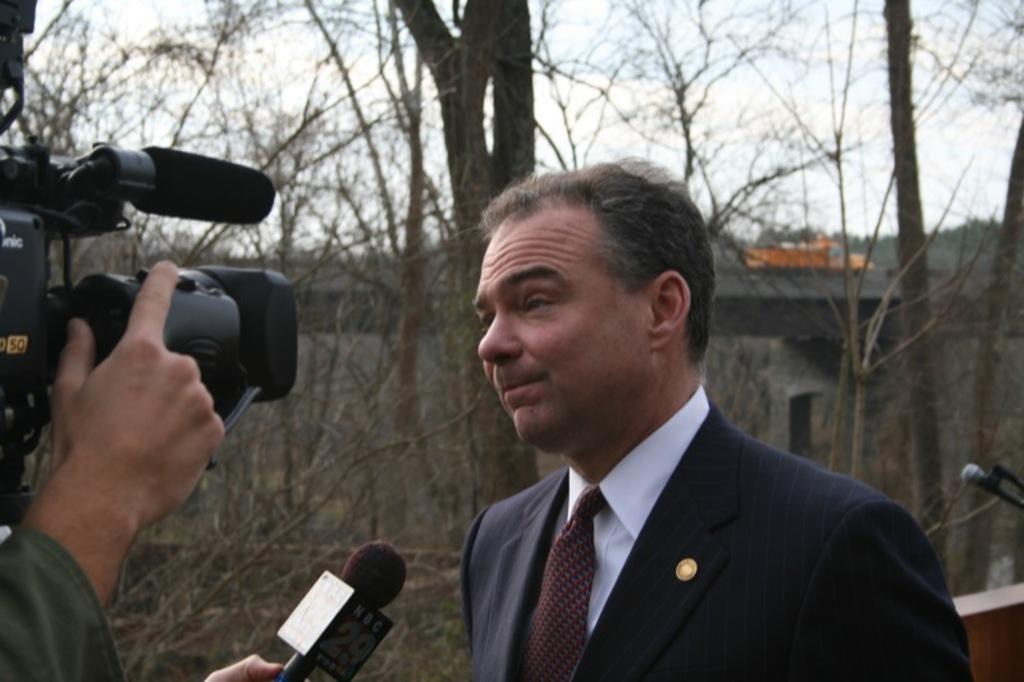How would you summarize this image in a sentence or two? In this image I can see a person. On the left side I can see a camera. On the right side, I can see a mike. In the background, I can see the trees and clouds in the sky. 